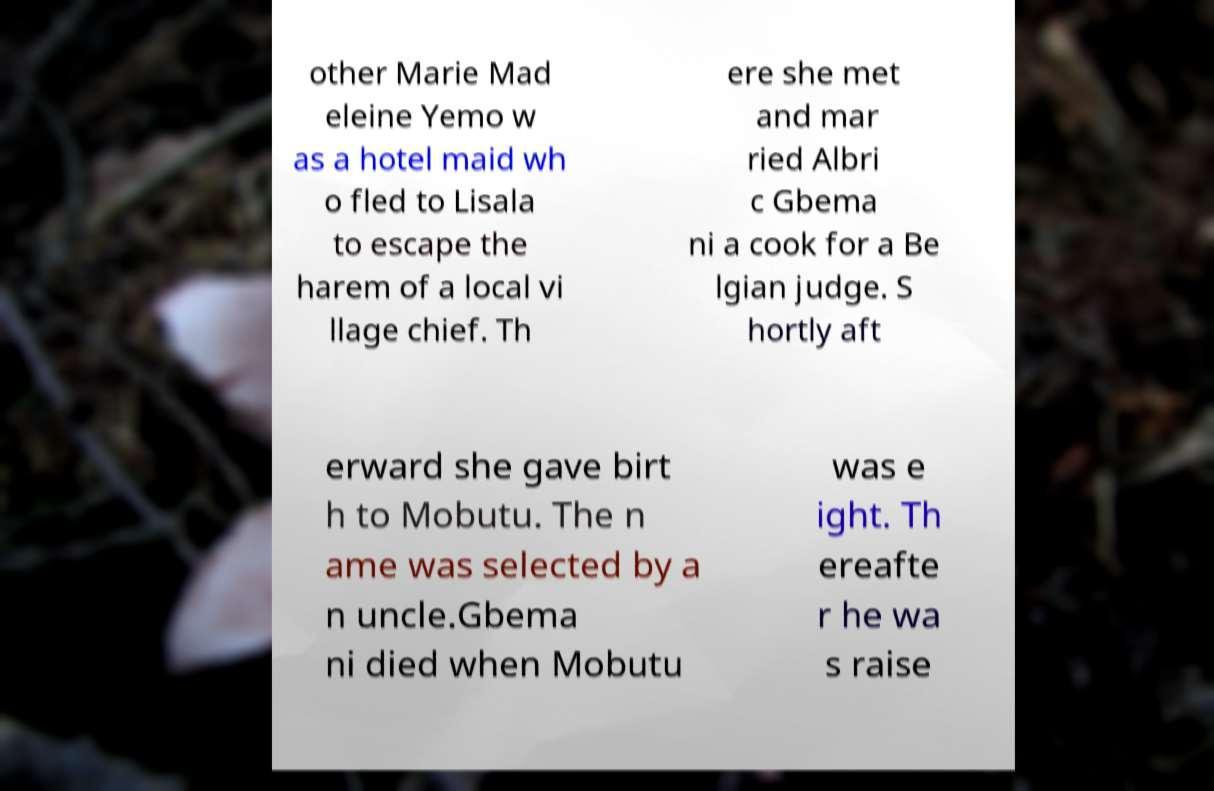Could you assist in decoding the text presented in this image and type it out clearly? other Marie Mad eleine Yemo w as a hotel maid wh o fled to Lisala to escape the harem of a local vi llage chief. Th ere she met and mar ried Albri c Gbema ni a cook for a Be lgian judge. S hortly aft erward she gave birt h to Mobutu. The n ame was selected by a n uncle.Gbema ni died when Mobutu was e ight. Th ereafte r he wa s raise 